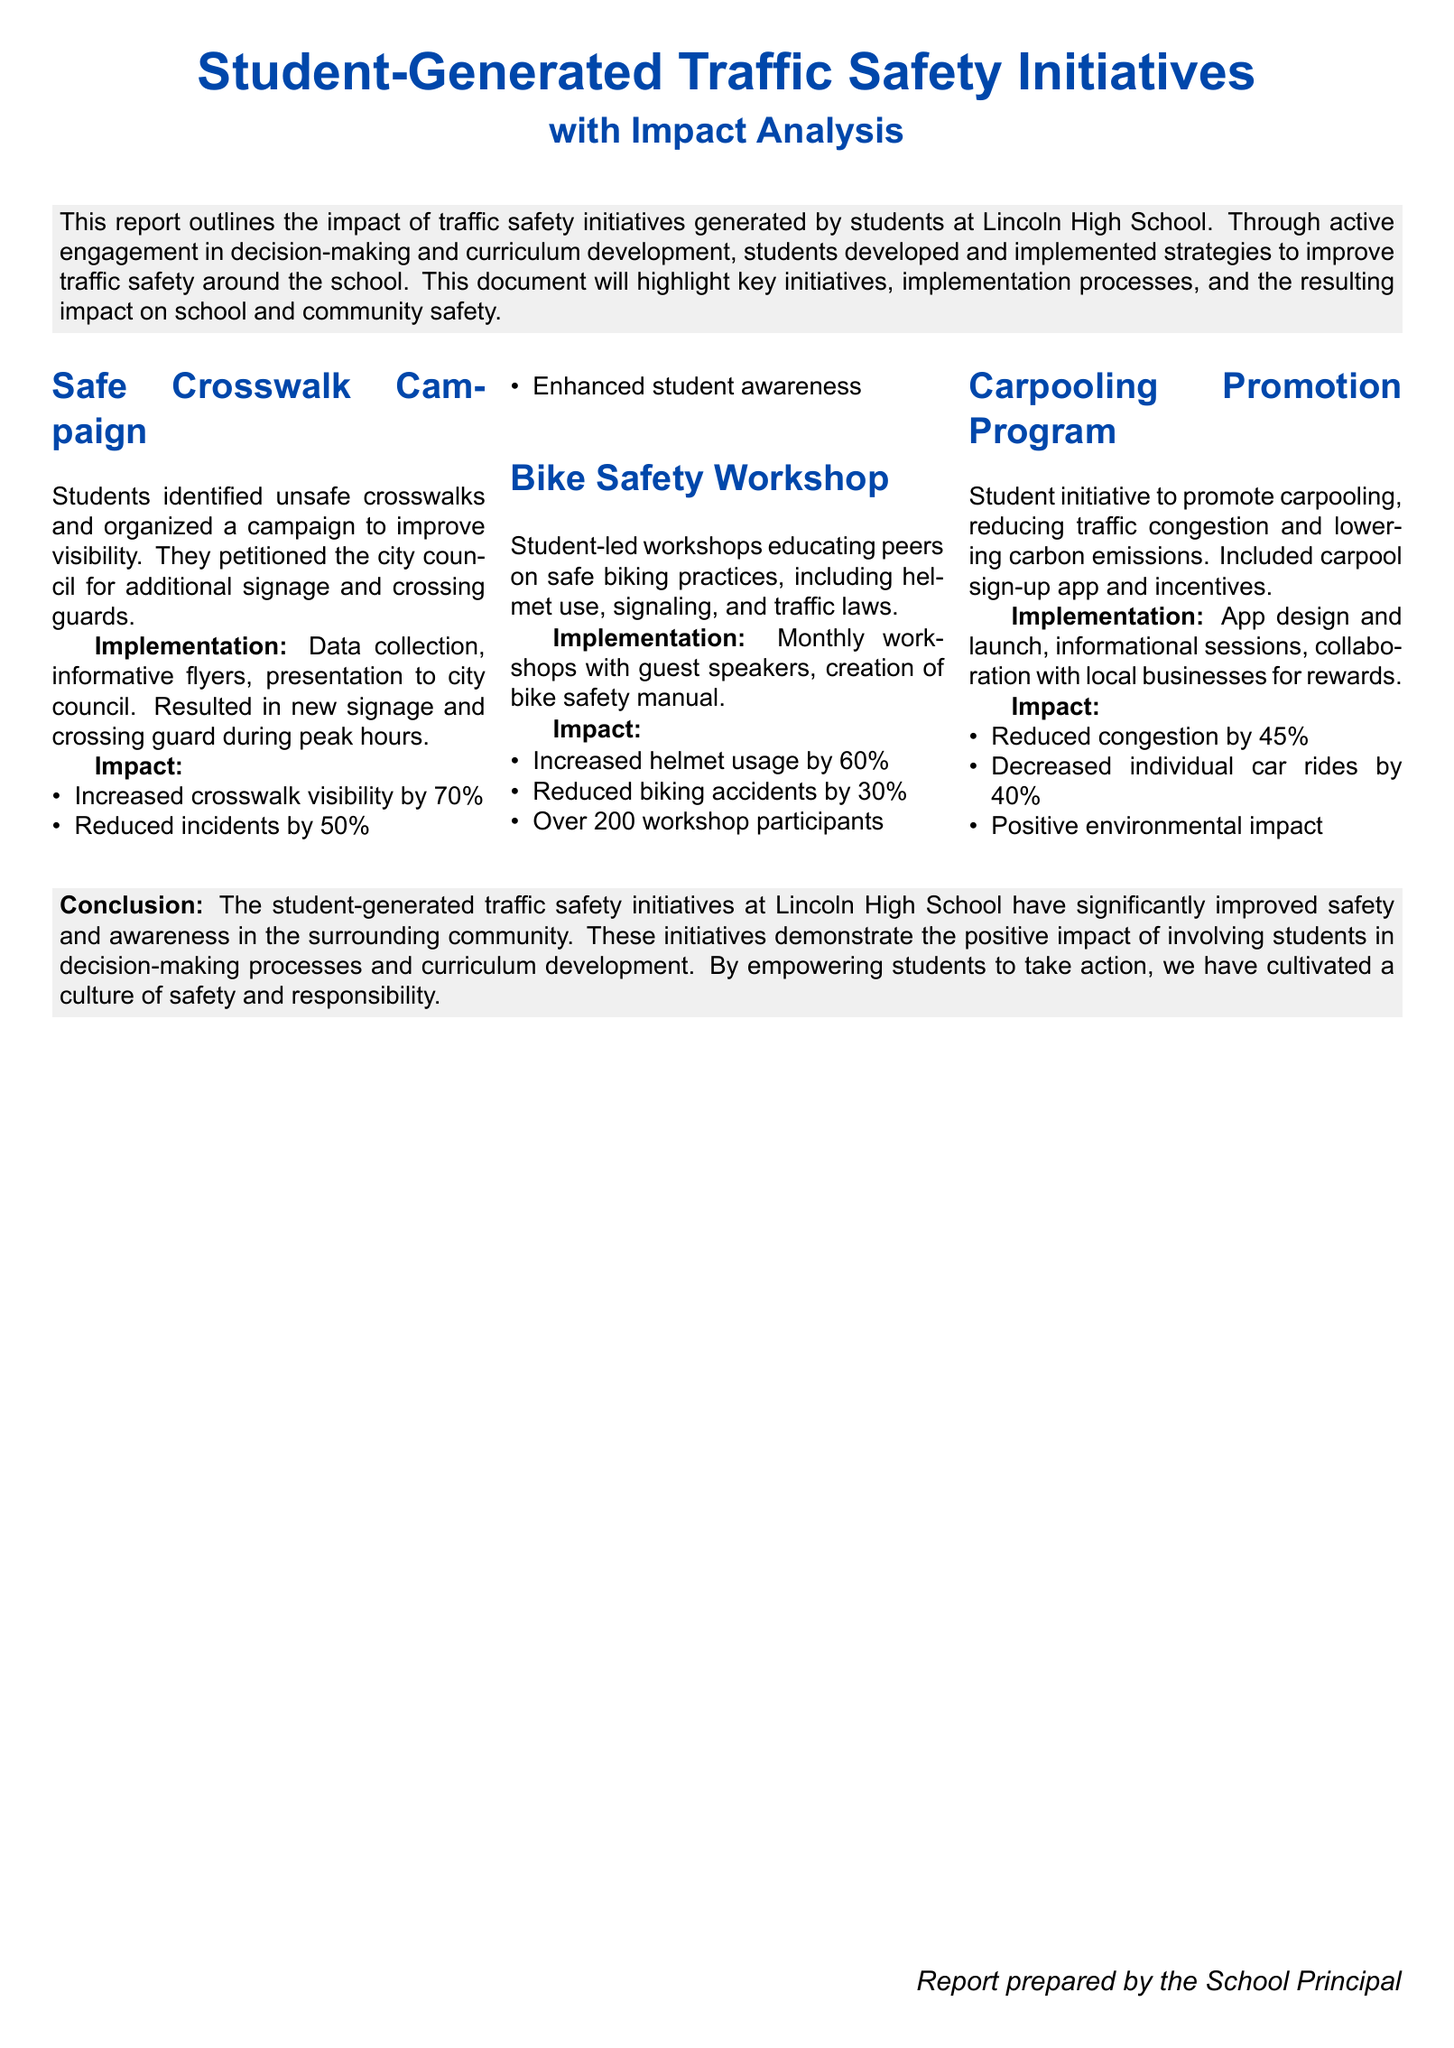What campaign aimed to improve crosswalk visibility? The document mentions the "Safe Crosswalk Campaign" which was organized by students to improve visibility at unsafe crosswalks.
Answer: Safe Crosswalk Campaign What was the percentage increase in helmet usage from the Bike Safety Workshop? According to the document, the initiative increased helmet usage by 60%.
Answer: 60% How many workshop participants were there for the Bike Safety Workshop? The report states there were over 200 participants in the workshops.
Answer: Over 200 What was the percentage reduction in biking accidents due to the bike safety initiative? The document specifies that the biking accidents were reduced by 30% as a result of the workshops.
Answer: 30% What environmental goal was achieved through the Carpooling Promotion Program? The document emphasizes a positive environmental impact resulting from the promotion of carpooling.
Answer: Positive environmental impact What percentage reduction in congestion was reported from the Carpooling Promotion Program? The document indicates a 45% reduction in congestion due to the student initiative.
Answer: 45% How did students engage in decision-making processes? Students developed and implemented strategies to improve traffic safety as part of their engagement.
Answer: Developed and implemented strategies What is the main focus of the report? The report primarily focuses on the impact of traffic safety initiatives generated by students at Lincoln High School.
Answer: Student-generated traffic safety initiatives What did the conclusion emphasize about the role of students in the report? The conclusion highlights the positive impact of involving students in decision-making processes and curriculum development.
Answer: Positive impact of involving students How was the new crossing guard implemented according to the Safe Crosswalk Campaign? The new crossing guard was implemented during peak hours as part of the campaign.
Answer: During peak hours 